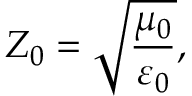<formula> <loc_0><loc_0><loc_500><loc_500>Z _ { 0 } = { \sqrt { \frac { \mu _ { 0 } } { \varepsilon _ { 0 } } } } ,</formula> 